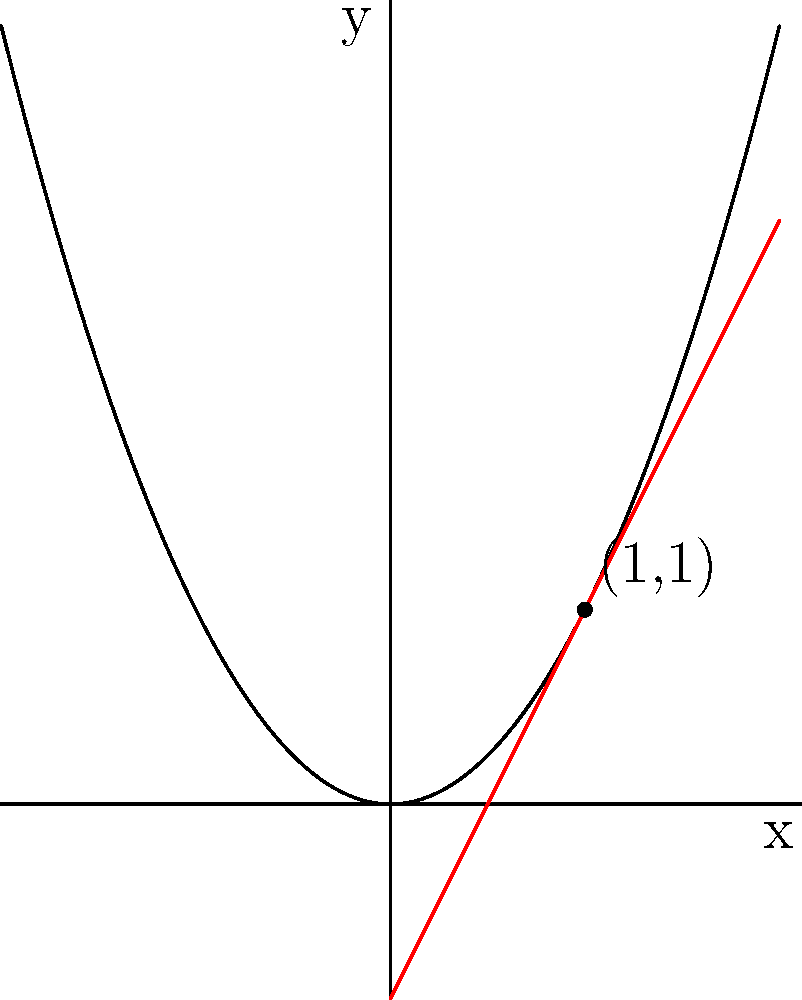As a freelance writer setting up a blog to discuss mathematical concepts, you want to create a post about instantaneous rate of change. Consider the function $f(x) = x^2$ shown in the graph. What is the instantaneous rate of change of $f(x)$ at the point $(1,1)$? Use the provided graph, which includes the tangent line at this point, to support your answer. To find the instantaneous rate of change at a point, we need to determine the slope of the tangent line at that point. Let's approach this step-by-step:

1) The tangent line is shown in red on the graph, passing through the point (1,1).

2) To find the slope of this line, we need two points. We already have (1,1), so let's find another point on the line.

3) The tangent line appears to intersect the y-axis at (-0.5, 0). We can use this point.

4) The slope formula is:
   $$m = \frac{y_2 - y_1}{x_2 - x_1}$$

5) Plugging in our points (1,1) and (-0.5,0):
   $$m = \frac{1 - 0}{1 - (-0.5)} = \frac{1}{1.5} = \frac{2}{3}$$

6) We can verify this by noting that the tangent line rises 2 units for every 1 unit it moves right, giving a slope of 2.

7) The instantaneous rate of change is equal to this slope.

Therefore, the instantaneous rate of change of $f(x) = x^2$ at the point (1,1) is 2.
Answer: 2 